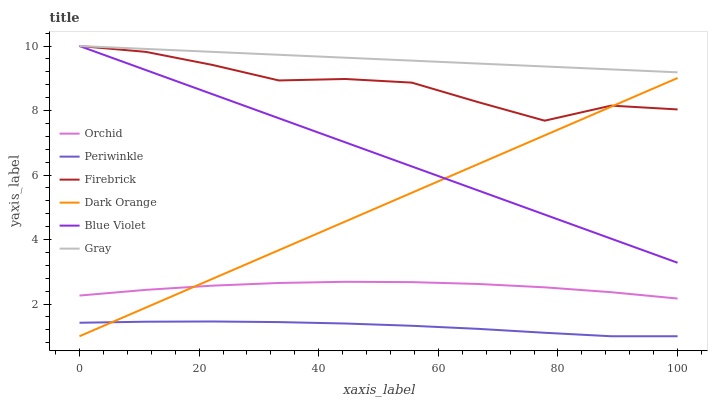Does Periwinkle have the minimum area under the curve?
Answer yes or no. Yes. Does Gray have the maximum area under the curve?
Answer yes or no. Yes. Does Firebrick have the minimum area under the curve?
Answer yes or no. No. Does Firebrick have the maximum area under the curve?
Answer yes or no. No. Is Blue Violet the smoothest?
Answer yes or no. Yes. Is Firebrick the roughest?
Answer yes or no. Yes. Is Gray the smoothest?
Answer yes or no. No. Is Gray the roughest?
Answer yes or no. No. Does Dark Orange have the lowest value?
Answer yes or no. Yes. Does Firebrick have the lowest value?
Answer yes or no. No. Does Blue Violet have the highest value?
Answer yes or no. Yes. Does Periwinkle have the highest value?
Answer yes or no. No. Is Periwinkle less than Blue Violet?
Answer yes or no. Yes. Is Gray greater than Periwinkle?
Answer yes or no. Yes. Does Blue Violet intersect Gray?
Answer yes or no. Yes. Is Blue Violet less than Gray?
Answer yes or no. No. Is Blue Violet greater than Gray?
Answer yes or no. No. Does Periwinkle intersect Blue Violet?
Answer yes or no. No. 